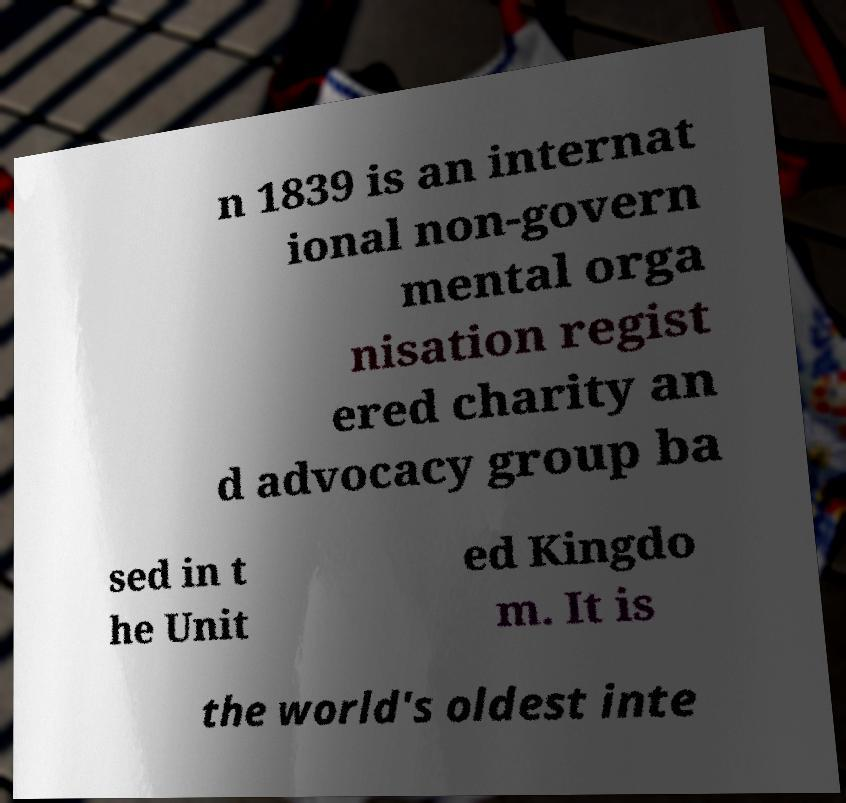Could you extract and type out the text from this image? n 1839 is an internat ional non-govern mental orga nisation regist ered charity an d advocacy group ba sed in t he Unit ed Kingdo m. It is the world's oldest inte 